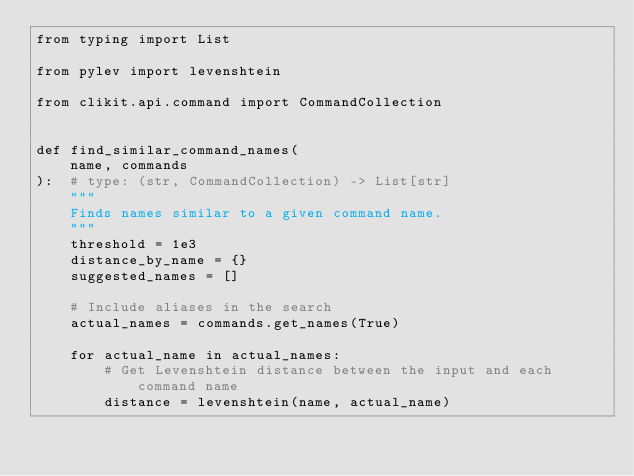Convert code to text. <code><loc_0><loc_0><loc_500><loc_500><_Python_>from typing import List

from pylev import levenshtein

from clikit.api.command import CommandCollection


def find_similar_command_names(
    name, commands
):  # type: (str, CommandCollection) -> List[str]
    """
    Finds names similar to a given command name.
    """
    threshold = 1e3
    distance_by_name = {}
    suggested_names = []

    # Include aliases in the search
    actual_names = commands.get_names(True)

    for actual_name in actual_names:
        # Get Levenshtein distance between the input and each command name
        distance = levenshtein(name, actual_name)
</code> 